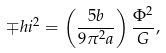<formula> <loc_0><loc_0><loc_500><loc_500>\mp h i ^ { 2 } = \left ( \frac { 5 b } { 9 \pi ^ { 2 } a } \right ) \frac { \Phi ^ { 2 } } { G } ,</formula> 